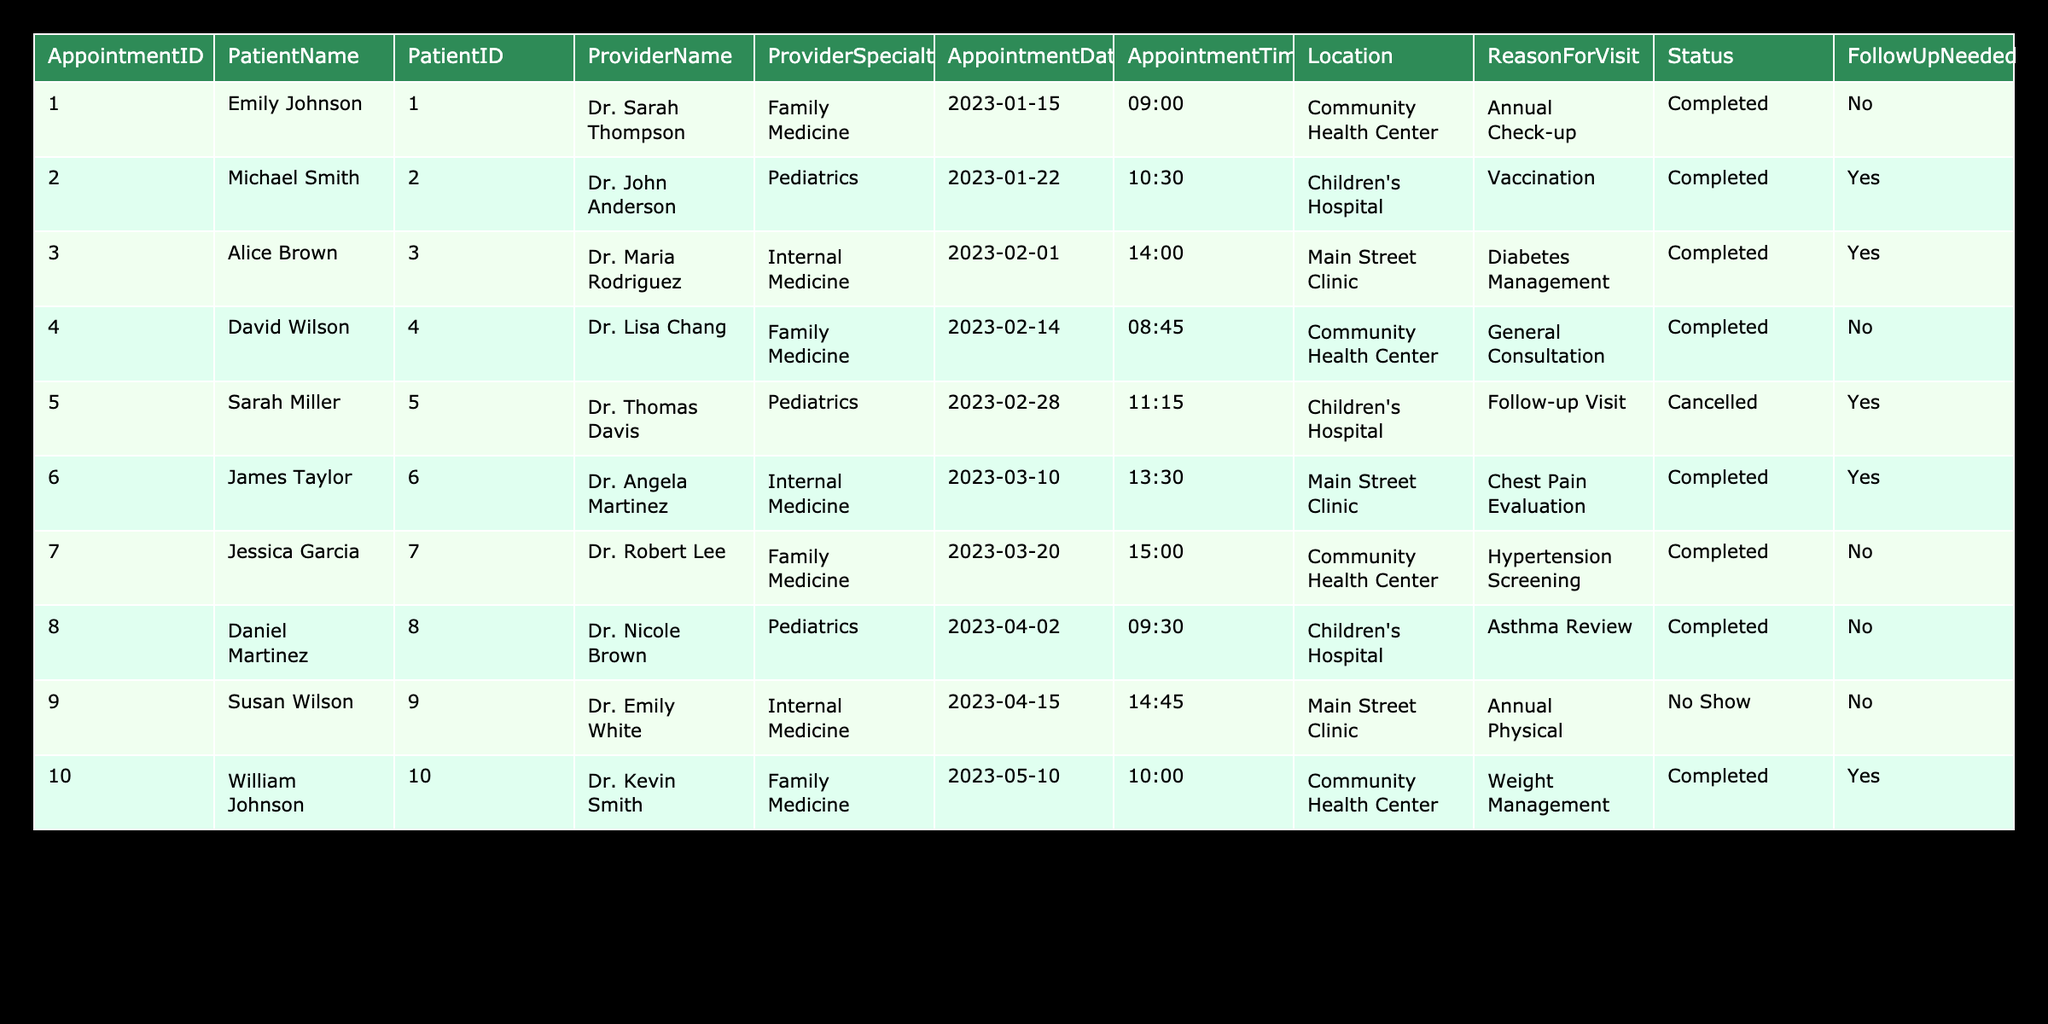What is the date of the appointment for Michael Smith? Michael Smith's appointment is listed in the table under the "AppointmentDate" column. Referring to the row corresponding to Michael Smith, the date is noted as "2023-01-22."
Answer: 2023-01-22 How many appointments were completed in February 2023? The table shows three appointments in February. They are for Alice Brown on February 1, David Wilson on February 14, and Sarah Miller's was cancelled. Thus, the completed appointments are those of Alice Brown and David Wilson.
Answer: 2 Did any patients not show up for their appointments? Referring to the "Status" column, the entry for Susan Wilson indicates "No Show." This means there was an instance where a patient did not show up for their appointment.
Answer: Yes What is the reason for the visit for the appointment with Dr. Kevin Smith? The appointment with Dr. Kevin Smith is noted in the table, and checking the "ReasonForVisit" column for AppointmentID 10 reveals that the reason is "Weight Management."
Answer: Weight Management How many follow-up visits were marked as completed, and how many were cancelled? From the table, there are two follow-up visits: one for Alice Brown that was completed and one for Sarah Miller that was cancelled. Therefore, completed follow-up visits are 1, and cancelled is 1.
Answer: Completed: 1, Cancelled: 1 What percentage of appointments in March 2023 required follow-up? There were two appointments in March (James Taylor and Jessica Garcia). Both required follow-up: James Taylor's as yes and Jessica Garcia's as no. So, there is 50% follow-up needed from the appointments in March.
Answer: 50% Which provider had the highest number of appointments in the table? By assessing the "ProviderName" column, Dr. Sarah Thompson and Dr. John Anderson each have one appointment, while other providers such as Dr. Angela Martinez and Dr. Kevin Smith have a single appointment too. Thus, there is no provider with more than one appointment.
Answer: None; all providers have 1 appointment each What is the average appointment time for the completed visits? The completed visit appointment times are 09:00, 10:30, 14:00, 08:45, 13:30, 15:00, 09:30, 10:00. Converting these to minutes since midnight: 540, 630, 840, 525, 810, 900, 570, 600. The average is (540 + 630 + 840 + 525 + 810 + 900 + 570 + 600) / 8 = 671.25 minutes, which converts back to approximately 11:11.
Answer: 11:11 